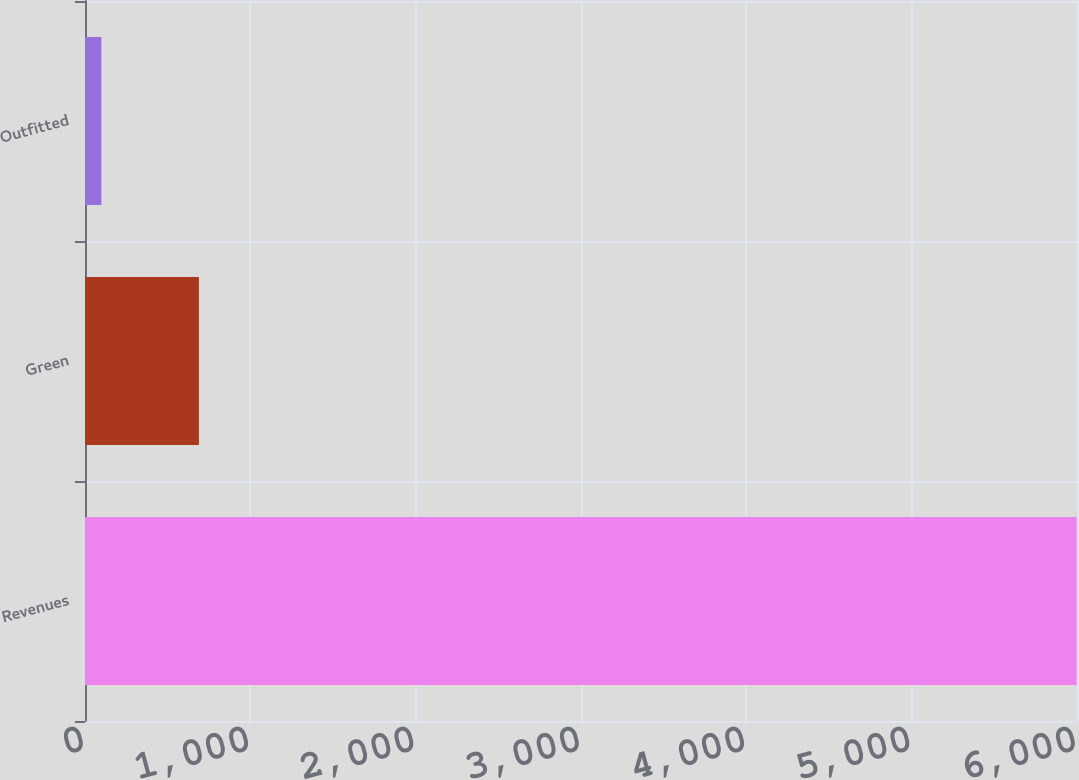Convert chart to OTSL. <chart><loc_0><loc_0><loc_500><loc_500><bar_chart><fcel>Revenues<fcel>Green<fcel>Outfitted<nl><fcel>5998<fcel>688.9<fcel>99<nl></chart> 